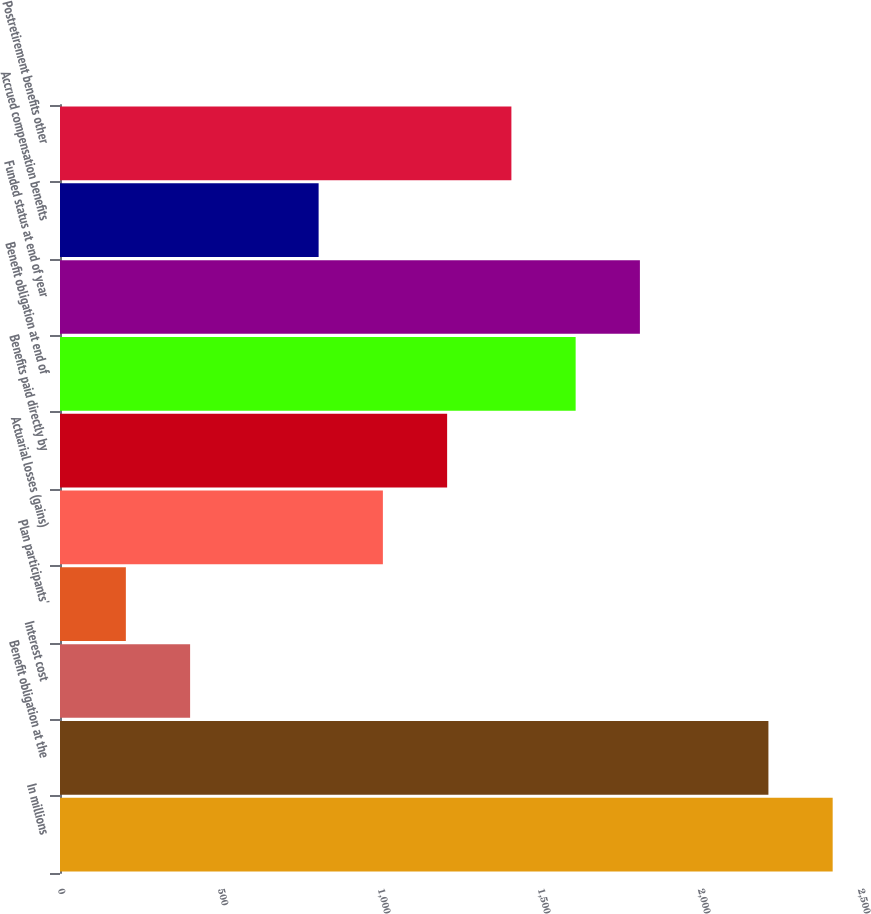<chart> <loc_0><loc_0><loc_500><loc_500><bar_chart><fcel>In millions<fcel>Benefit obligation at the<fcel>Interest cost<fcel>Plan participants'<fcel>Actuarial losses (gains)<fcel>Benefits paid directly by<fcel>Benefit obligation at end of<fcel>Funded status at end of year<fcel>Accrued compensation benefits<fcel>Postretirement benefits other<nl><fcel>2414.6<fcel>2213.8<fcel>406.6<fcel>205.8<fcel>1009<fcel>1209.8<fcel>1611.4<fcel>1812.2<fcel>808.2<fcel>1410.6<nl></chart> 